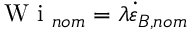Convert formula to latex. <formula><loc_0><loc_0><loc_500><loc_500>W i _ { n o m } = \lambda \dot { \varepsilon } _ { B , n o m }</formula> 